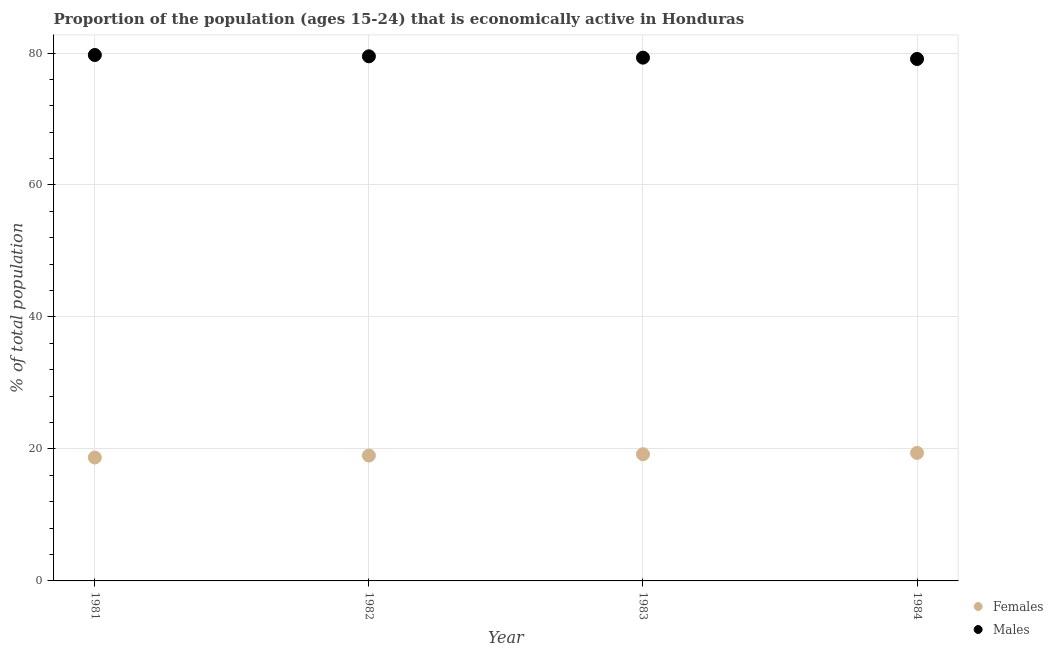How many different coloured dotlines are there?
Make the answer very short. 2. Is the number of dotlines equal to the number of legend labels?
Give a very brief answer. Yes. What is the percentage of economically active female population in 1981?
Offer a terse response. 18.7. Across all years, what is the maximum percentage of economically active male population?
Your response must be concise. 79.7. Across all years, what is the minimum percentage of economically active male population?
Give a very brief answer. 79.1. In which year was the percentage of economically active male population maximum?
Offer a terse response. 1981. What is the total percentage of economically active male population in the graph?
Give a very brief answer. 317.6. What is the difference between the percentage of economically active male population in 1983 and that in 1984?
Make the answer very short. 0.2. What is the difference between the percentage of economically active male population in 1982 and the percentage of economically active female population in 1981?
Provide a succinct answer. 60.8. What is the average percentage of economically active male population per year?
Keep it short and to the point. 79.4. In the year 1982, what is the difference between the percentage of economically active male population and percentage of economically active female population?
Provide a short and direct response. 60.5. What is the ratio of the percentage of economically active female population in 1981 to that in 1983?
Your answer should be compact. 0.97. Is the percentage of economically active male population in 1981 less than that in 1982?
Your response must be concise. No. What is the difference between the highest and the second highest percentage of economically active male population?
Your response must be concise. 0.2. What is the difference between the highest and the lowest percentage of economically active male population?
Your answer should be compact. 0.6. In how many years, is the percentage of economically active female population greater than the average percentage of economically active female population taken over all years?
Keep it short and to the point. 2. Is the sum of the percentage of economically active male population in 1982 and 1983 greater than the maximum percentage of economically active female population across all years?
Provide a succinct answer. Yes. Is the percentage of economically active male population strictly greater than the percentage of economically active female population over the years?
Ensure brevity in your answer.  Yes. Is the percentage of economically active male population strictly less than the percentage of economically active female population over the years?
Provide a short and direct response. No. How many dotlines are there?
Ensure brevity in your answer.  2. What is the difference between two consecutive major ticks on the Y-axis?
Offer a very short reply. 20. Does the graph contain grids?
Ensure brevity in your answer.  Yes. Where does the legend appear in the graph?
Your answer should be very brief. Bottom right. What is the title of the graph?
Give a very brief answer. Proportion of the population (ages 15-24) that is economically active in Honduras. What is the label or title of the X-axis?
Provide a succinct answer. Year. What is the label or title of the Y-axis?
Make the answer very short. % of total population. What is the % of total population of Females in 1981?
Your answer should be compact. 18.7. What is the % of total population in Males in 1981?
Offer a very short reply. 79.7. What is the % of total population of Females in 1982?
Your response must be concise. 19. What is the % of total population in Males in 1982?
Keep it short and to the point. 79.5. What is the % of total population of Females in 1983?
Offer a terse response. 19.2. What is the % of total population of Males in 1983?
Your answer should be very brief. 79.3. What is the % of total population in Females in 1984?
Keep it short and to the point. 19.4. What is the % of total population of Males in 1984?
Your answer should be very brief. 79.1. Across all years, what is the maximum % of total population of Females?
Ensure brevity in your answer.  19.4. Across all years, what is the maximum % of total population in Males?
Provide a short and direct response. 79.7. Across all years, what is the minimum % of total population in Females?
Ensure brevity in your answer.  18.7. Across all years, what is the minimum % of total population of Males?
Your answer should be compact. 79.1. What is the total % of total population in Females in the graph?
Give a very brief answer. 76.3. What is the total % of total population of Males in the graph?
Offer a terse response. 317.6. What is the difference between the % of total population in Females in 1981 and that in 1982?
Your answer should be compact. -0.3. What is the difference between the % of total population of Males in 1981 and that in 1982?
Keep it short and to the point. 0.2. What is the difference between the % of total population of Males in 1981 and that in 1984?
Offer a very short reply. 0.6. What is the difference between the % of total population of Females in 1982 and that in 1984?
Give a very brief answer. -0.4. What is the difference between the % of total population of Females in 1983 and that in 1984?
Offer a terse response. -0.2. What is the difference between the % of total population in Females in 1981 and the % of total population in Males in 1982?
Give a very brief answer. -60.8. What is the difference between the % of total population of Females in 1981 and the % of total population of Males in 1983?
Provide a succinct answer. -60.6. What is the difference between the % of total population of Females in 1981 and the % of total population of Males in 1984?
Provide a succinct answer. -60.4. What is the difference between the % of total population of Females in 1982 and the % of total population of Males in 1983?
Your response must be concise. -60.3. What is the difference between the % of total population of Females in 1982 and the % of total population of Males in 1984?
Your response must be concise. -60.1. What is the difference between the % of total population in Females in 1983 and the % of total population in Males in 1984?
Provide a short and direct response. -59.9. What is the average % of total population in Females per year?
Your answer should be compact. 19.07. What is the average % of total population in Males per year?
Your answer should be compact. 79.4. In the year 1981, what is the difference between the % of total population in Females and % of total population in Males?
Give a very brief answer. -61. In the year 1982, what is the difference between the % of total population of Females and % of total population of Males?
Offer a terse response. -60.5. In the year 1983, what is the difference between the % of total population of Females and % of total population of Males?
Make the answer very short. -60.1. In the year 1984, what is the difference between the % of total population of Females and % of total population of Males?
Keep it short and to the point. -59.7. What is the ratio of the % of total population of Females in 1981 to that in 1982?
Offer a terse response. 0.98. What is the ratio of the % of total population in Females in 1981 to that in 1984?
Provide a succinct answer. 0.96. What is the ratio of the % of total population in Males in 1981 to that in 1984?
Keep it short and to the point. 1.01. What is the ratio of the % of total population of Females in 1982 to that in 1983?
Provide a short and direct response. 0.99. What is the ratio of the % of total population in Males in 1982 to that in 1983?
Ensure brevity in your answer.  1. What is the ratio of the % of total population in Females in 1982 to that in 1984?
Keep it short and to the point. 0.98. What is the ratio of the % of total population in Females in 1983 to that in 1984?
Give a very brief answer. 0.99. What is the ratio of the % of total population in Males in 1983 to that in 1984?
Give a very brief answer. 1. What is the difference between the highest and the lowest % of total population of Females?
Your answer should be compact. 0.7. 